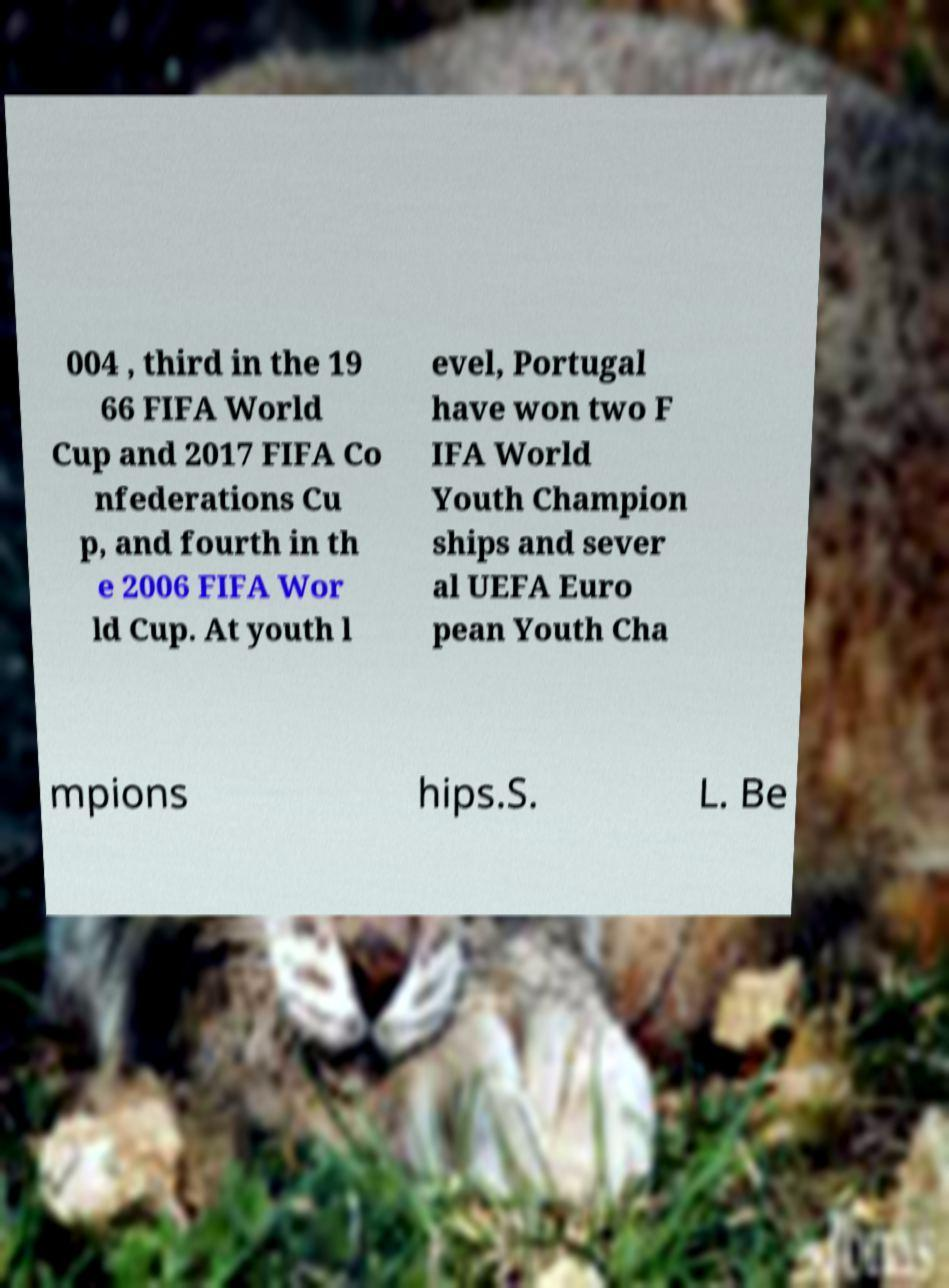Please read and relay the text visible in this image. What does it say? 004 , third in the 19 66 FIFA World Cup and 2017 FIFA Co nfederations Cu p, and fourth in th e 2006 FIFA Wor ld Cup. At youth l evel, Portugal have won two F IFA World Youth Champion ships and sever al UEFA Euro pean Youth Cha mpions hips.S. L. Be 